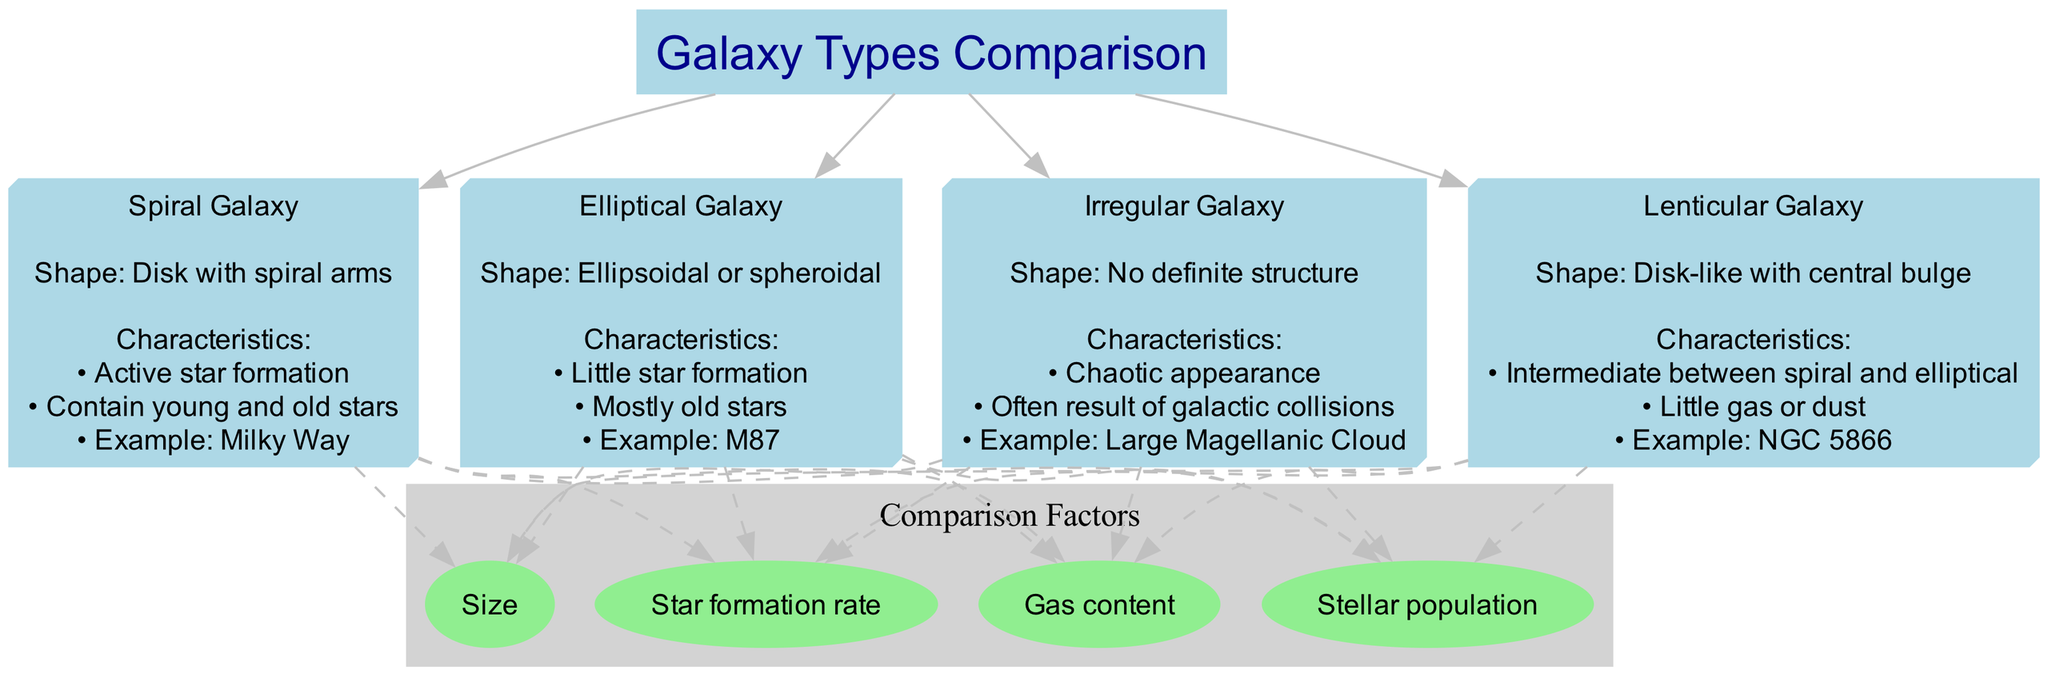What is the shape of a Spiral Galaxy? The diagram states that a Spiral Galaxy has a "Disk with spiral arms" as its shape. This information is directly presented in the node that describes Spiral Galaxies.
Answer: Disk with spiral arms Which galaxy type contains mostly old stars? The node for the Elliptical Galaxy specifies that it has "Mostly old stars" as a characteristic. By looking specifically at this node, we can find the answer.
Answer: Elliptical Galaxy How many galaxy types are shown in the diagram? By counting the individual nodes representing the galaxy types, we see there are four types listed: Spiral, Elliptical, Irregular, and Lenticular. Therefore, the total is four.
Answer: 4 What characteristic is common to both Spiral and Lenticular Galaxies? Upon reviewing the characteristics of both Spiral and Lenticular Galaxies, they both have "Active star formation" (for Spiral) and the Lenticular has a "Intermediate between spiral and elliptical," indicating some ongoing formation in different contexts. Thus, while star formation is more prominent in Spirals, the context of star dynamics is common in both.
Answer: Star formation What is the example of an Irregular Galaxy? The Irregular Galaxy node specifically mentions "Example: Large Magellanic Cloud," which can be directly referenced for this answer.
Answer: Large Magellanic Cloud In terms of gas content, which galaxy type has little gas or dust? The diagram identifies in the characteristics of the Lenticular Galaxy that there is "Little gas or dust," which answers the question about gas content.
Answer: Lenticular Galaxy How many comparison factors are included in the diagram? The comparison factors section lists four distinct factors: Size, Star formation rate, Gas content, and Stellar population. Thus, we can conclude there are four factors.
Answer: 4 Which galaxy type is an example of M87? The Elliptical Galaxy node states "Example: M87" as one of its characteristics. By referencing the node directly, we can identify this example.
Answer: M87 What do the dashed lines in the diagram represent? The dashed lines connect galaxy types to comparison factors, signifying the relationship and various comparison points among them based on characteristics like size, star formation rate, gas content, and stellar population.
Answer: Relationships between galaxy types and factors 